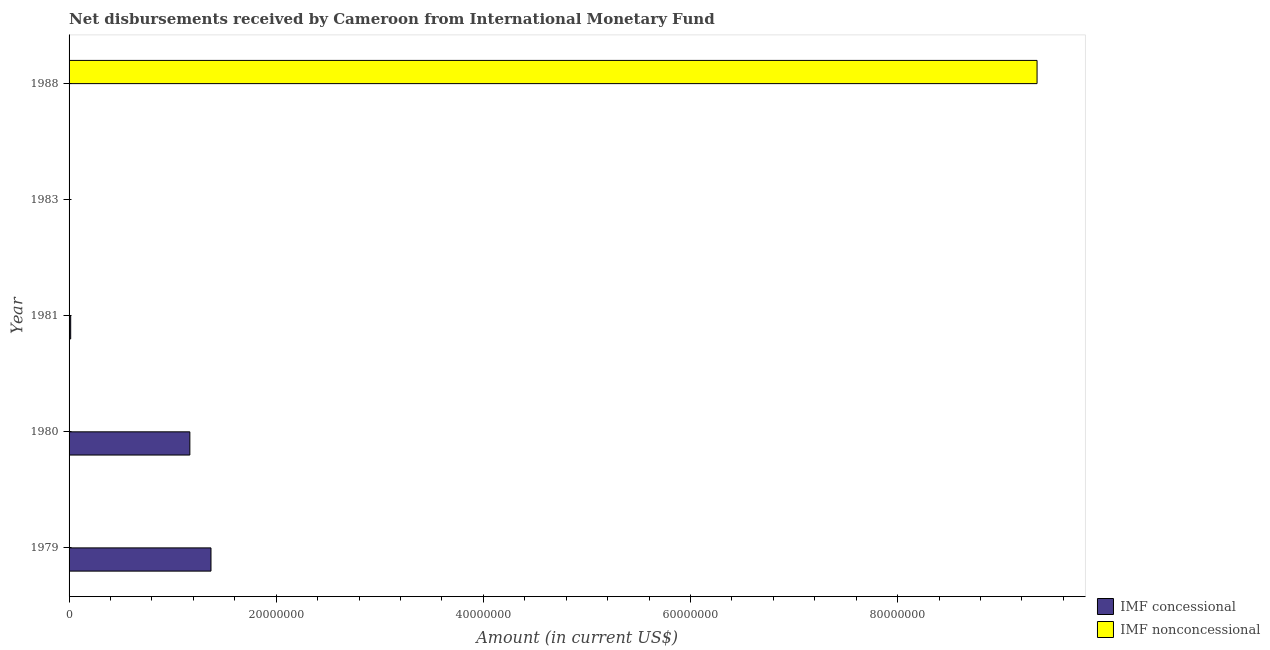Are the number of bars per tick equal to the number of legend labels?
Make the answer very short. No. What is the label of the 5th group of bars from the top?
Provide a short and direct response. 1979. In how many cases, is the number of bars for a given year not equal to the number of legend labels?
Provide a short and direct response. 5. What is the net non concessional disbursements from imf in 1983?
Offer a terse response. 0. Across all years, what is the maximum net non concessional disbursements from imf?
Provide a succinct answer. 9.35e+07. What is the total net non concessional disbursements from imf in the graph?
Keep it short and to the point. 9.35e+07. What is the difference between the net concessional disbursements from imf in 1980 and that in 1981?
Offer a terse response. 1.15e+07. What is the difference between the net concessional disbursements from imf in 1979 and the net non concessional disbursements from imf in 1988?
Provide a succinct answer. -7.98e+07. What is the average net concessional disbursements from imf per year?
Ensure brevity in your answer.  5.10e+06. What is the difference between the highest and the second highest net concessional disbursements from imf?
Provide a succinct answer. 2.04e+06. What is the difference between the highest and the lowest net non concessional disbursements from imf?
Keep it short and to the point. 9.35e+07. In how many years, is the net non concessional disbursements from imf greater than the average net non concessional disbursements from imf taken over all years?
Make the answer very short. 1. How many years are there in the graph?
Your answer should be compact. 5. What is the difference between two consecutive major ticks on the X-axis?
Offer a terse response. 2.00e+07. Does the graph contain any zero values?
Your answer should be compact. Yes. Where does the legend appear in the graph?
Ensure brevity in your answer.  Bottom right. What is the title of the graph?
Your answer should be compact. Net disbursements received by Cameroon from International Monetary Fund. What is the label or title of the X-axis?
Make the answer very short. Amount (in current US$). What is the Amount (in current US$) in IMF concessional in 1979?
Make the answer very short. 1.37e+07. What is the Amount (in current US$) in IMF concessional in 1980?
Ensure brevity in your answer.  1.17e+07. What is the Amount (in current US$) of IMF nonconcessional in 1980?
Give a very brief answer. 0. What is the Amount (in current US$) in IMF concessional in 1981?
Offer a very short reply. 1.56e+05. What is the Amount (in current US$) in IMF nonconcessional in 1981?
Your response must be concise. 0. What is the Amount (in current US$) of IMF concessional in 1983?
Make the answer very short. 0. What is the Amount (in current US$) in IMF concessional in 1988?
Make the answer very short. 0. What is the Amount (in current US$) in IMF nonconcessional in 1988?
Give a very brief answer. 9.35e+07. Across all years, what is the maximum Amount (in current US$) of IMF concessional?
Offer a very short reply. 1.37e+07. Across all years, what is the maximum Amount (in current US$) of IMF nonconcessional?
Offer a very short reply. 9.35e+07. Across all years, what is the minimum Amount (in current US$) in IMF concessional?
Keep it short and to the point. 0. What is the total Amount (in current US$) in IMF concessional in the graph?
Give a very brief answer. 2.55e+07. What is the total Amount (in current US$) of IMF nonconcessional in the graph?
Offer a terse response. 9.35e+07. What is the difference between the Amount (in current US$) in IMF concessional in 1979 and that in 1980?
Provide a succinct answer. 2.04e+06. What is the difference between the Amount (in current US$) of IMF concessional in 1979 and that in 1981?
Your answer should be very brief. 1.35e+07. What is the difference between the Amount (in current US$) in IMF concessional in 1980 and that in 1981?
Your answer should be compact. 1.15e+07. What is the difference between the Amount (in current US$) of IMF concessional in 1979 and the Amount (in current US$) of IMF nonconcessional in 1988?
Offer a terse response. -7.98e+07. What is the difference between the Amount (in current US$) in IMF concessional in 1980 and the Amount (in current US$) in IMF nonconcessional in 1988?
Offer a very short reply. -8.18e+07. What is the difference between the Amount (in current US$) in IMF concessional in 1981 and the Amount (in current US$) in IMF nonconcessional in 1988?
Your answer should be compact. -9.33e+07. What is the average Amount (in current US$) of IMF concessional per year?
Your answer should be very brief. 5.10e+06. What is the average Amount (in current US$) of IMF nonconcessional per year?
Keep it short and to the point. 1.87e+07. What is the ratio of the Amount (in current US$) of IMF concessional in 1979 to that in 1980?
Keep it short and to the point. 1.17. What is the ratio of the Amount (in current US$) in IMF concessional in 1979 to that in 1981?
Your answer should be very brief. 87.83. What is the ratio of the Amount (in current US$) of IMF concessional in 1980 to that in 1981?
Provide a succinct answer. 74.76. What is the difference between the highest and the second highest Amount (in current US$) of IMF concessional?
Your response must be concise. 2.04e+06. What is the difference between the highest and the lowest Amount (in current US$) in IMF concessional?
Provide a short and direct response. 1.37e+07. What is the difference between the highest and the lowest Amount (in current US$) in IMF nonconcessional?
Your answer should be compact. 9.35e+07. 